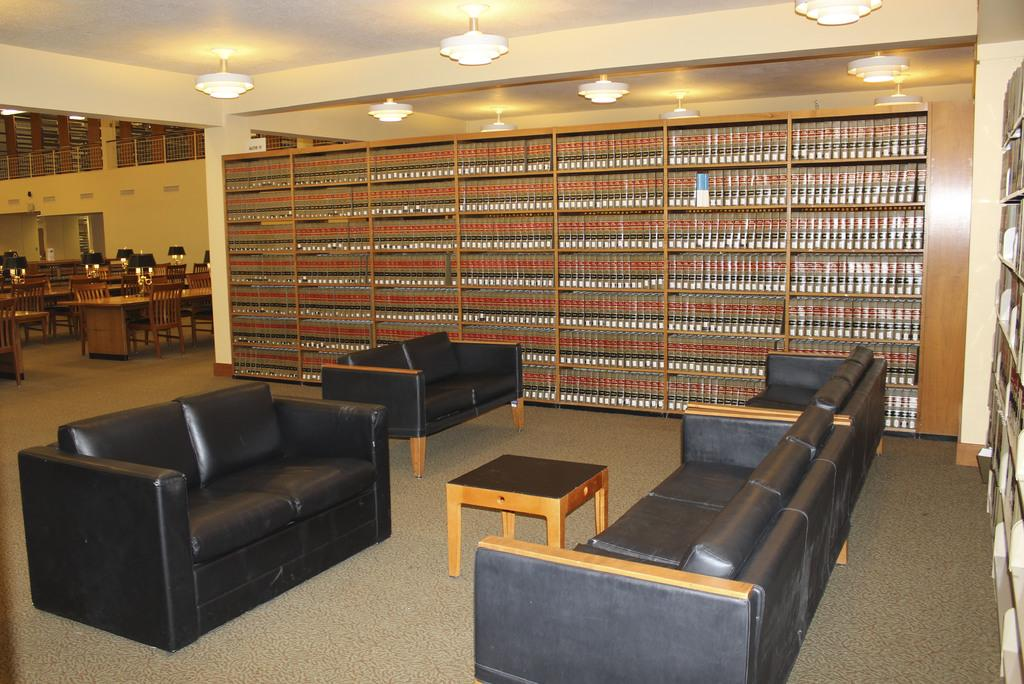What type of furniture is present in the image? There is a sofa in the image. What can be seen on the shelf in the image? There are many books on a shelf in the image. What type of glove is being used to aid in the learning process in the image? There is no glove or learning process depicted in the image; it only features a sofa and books on a shelf. 